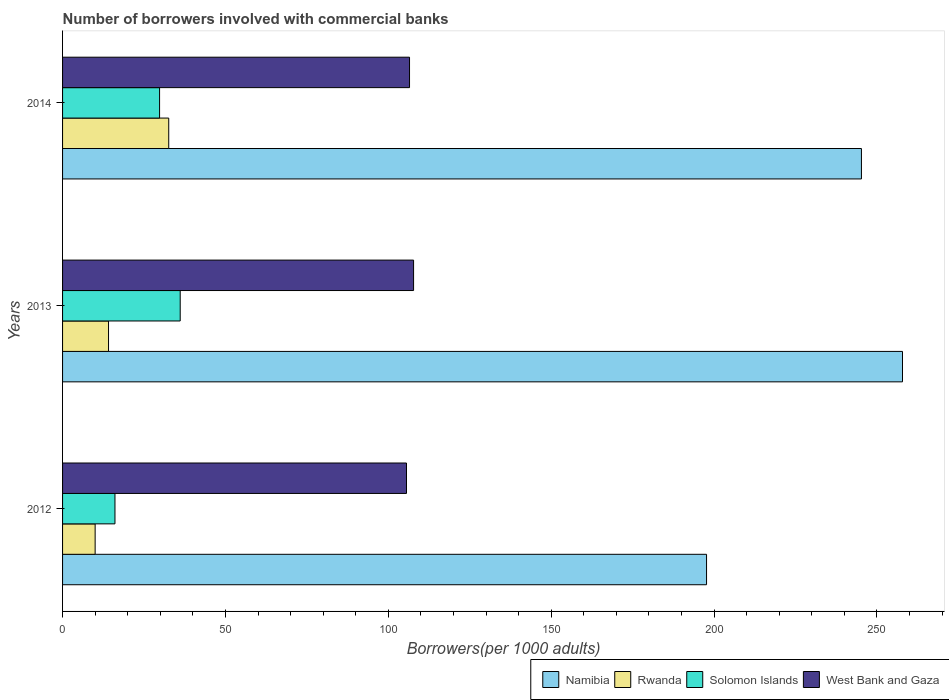How many different coloured bars are there?
Your answer should be very brief. 4. Are the number of bars per tick equal to the number of legend labels?
Your answer should be very brief. Yes. Are the number of bars on each tick of the Y-axis equal?
Ensure brevity in your answer.  Yes. How many bars are there on the 2nd tick from the top?
Your response must be concise. 4. How many bars are there on the 3rd tick from the bottom?
Provide a succinct answer. 4. In how many cases, is the number of bars for a given year not equal to the number of legend labels?
Ensure brevity in your answer.  0. What is the number of borrowers involved with commercial banks in Solomon Islands in 2013?
Give a very brief answer. 36.11. Across all years, what is the maximum number of borrowers involved with commercial banks in Rwanda?
Your answer should be compact. 32.59. Across all years, what is the minimum number of borrowers involved with commercial banks in West Bank and Gaza?
Make the answer very short. 105.58. In which year was the number of borrowers involved with commercial banks in Namibia maximum?
Provide a short and direct response. 2013. In which year was the number of borrowers involved with commercial banks in Solomon Islands minimum?
Your answer should be compact. 2012. What is the total number of borrowers involved with commercial banks in Solomon Islands in the graph?
Offer a terse response. 81.98. What is the difference between the number of borrowers involved with commercial banks in Solomon Islands in 2012 and that in 2014?
Keep it short and to the point. -13.69. What is the difference between the number of borrowers involved with commercial banks in Solomon Islands in 2014 and the number of borrowers involved with commercial banks in Namibia in 2012?
Your answer should be compact. -167.91. What is the average number of borrowers involved with commercial banks in West Bank and Gaza per year?
Provide a short and direct response. 106.61. In the year 2014, what is the difference between the number of borrowers involved with commercial banks in Namibia and number of borrowers involved with commercial banks in West Bank and Gaza?
Your response must be concise. 138.73. In how many years, is the number of borrowers involved with commercial banks in Solomon Islands greater than 110 ?
Your answer should be compact. 0. What is the ratio of the number of borrowers involved with commercial banks in Solomon Islands in 2012 to that in 2013?
Your response must be concise. 0.45. Is the difference between the number of borrowers involved with commercial banks in Namibia in 2013 and 2014 greater than the difference between the number of borrowers involved with commercial banks in West Bank and Gaza in 2013 and 2014?
Offer a terse response. Yes. What is the difference between the highest and the second highest number of borrowers involved with commercial banks in West Bank and Gaza?
Give a very brief answer. 1.24. What is the difference between the highest and the lowest number of borrowers involved with commercial banks in Rwanda?
Provide a short and direct response. 22.59. In how many years, is the number of borrowers involved with commercial banks in West Bank and Gaza greater than the average number of borrowers involved with commercial banks in West Bank and Gaza taken over all years?
Make the answer very short. 1. Is the sum of the number of borrowers involved with commercial banks in Rwanda in 2013 and 2014 greater than the maximum number of borrowers involved with commercial banks in West Bank and Gaza across all years?
Offer a very short reply. No. What does the 3rd bar from the top in 2012 represents?
Offer a very short reply. Rwanda. What does the 1st bar from the bottom in 2012 represents?
Your answer should be very brief. Namibia. Is it the case that in every year, the sum of the number of borrowers involved with commercial banks in Rwanda and number of borrowers involved with commercial banks in Namibia is greater than the number of borrowers involved with commercial banks in Solomon Islands?
Provide a short and direct response. Yes. Are all the bars in the graph horizontal?
Make the answer very short. Yes. How many years are there in the graph?
Ensure brevity in your answer.  3. What is the difference between two consecutive major ticks on the X-axis?
Make the answer very short. 50. Does the graph contain any zero values?
Make the answer very short. No. Does the graph contain grids?
Offer a very short reply. No. How are the legend labels stacked?
Your response must be concise. Horizontal. What is the title of the graph?
Provide a short and direct response. Number of borrowers involved with commercial banks. Does "Gabon" appear as one of the legend labels in the graph?
Give a very brief answer. No. What is the label or title of the X-axis?
Keep it short and to the point. Borrowers(per 1000 adults). What is the Borrowers(per 1000 adults) in Namibia in 2012?
Offer a very short reply. 197.69. What is the Borrowers(per 1000 adults) in Rwanda in 2012?
Your response must be concise. 10. What is the Borrowers(per 1000 adults) in Solomon Islands in 2012?
Offer a very short reply. 16.09. What is the Borrowers(per 1000 adults) in West Bank and Gaza in 2012?
Keep it short and to the point. 105.58. What is the Borrowers(per 1000 adults) of Namibia in 2013?
Give a very brief answer. 257.84. What is the Borrowers(per 1000 adults) of Rwanda in 2013?
Your answer should be compact. 14.11. What is the Borrowers(per 1000 adults) of Solomon Islands in 2013?
Keep it short and to the point. 36.11. What is the Borrowers(per 1000 adults) of West Bank and Gaza in 2013?
Keep it short and to the point. 107.75. What is the Borrowers(per 1000 adults) in Namibia in 2014?
Provide a short and direct response. 245.24. What is the Borrowers(per 1000 adults) of Rwanda in 2014?
Ensure brevity in your answer.  32.59. What is the Borrowers(per 1000 adults) of Solomon Islands in 2014?
Offer a terse response. 29.78. What is the Borrowers(per 1000 adults) of West Bank and Gaza in 2014?
Keep it short and to the point. 106.51. Across all years, what is the maximum Borrowers(per 1000 adults) in Namibia?
Ensure brevity in your answer.  257.84. Across all years, what is the maximum Borrowers(per 1000 adults) of Rwanda?
Your response must be concise. 32.59. Across all years, what is the maximum Borrowers(per 1000 adults) of Solomon Islands?
Offer a very short reply. 36.11. Across all years, what is the maximum Borrowers(per 1000 adults) of West Bank and Gaza?
Your response must be concise. 107.75. Across all years, what is the minimum Borrowers(per 1000 adults) in Namibia?
Ensure brevity in your answer.  197.69. Across all years, what is the minimum Borrowers(per 1000 adults) in Rwanda?
Make the answer very short. 10. Across all years, what is the minimum Borrowers(per 1000 adults) in Solomon Islands?
Offer a terse response. 16.09. Across all years, what is the minimum Borrowers(per 1000 adults) in West Bank and Gaza?
Keep it short and to the point. 105.58. What is the total Borrowers(per 1000 adults) of Namibia in the graph?
Offer a very short reply. 700.77. What is the total Borrowers(per 1000 adults) in Rwanda in the graph?
Offer a terse response. 56.7. What is the total Borrowers(per 1000 adults) in Solomon Islands in the graph?
Your answer should be compact. 81.98. What is the total Borrowers(per 1000 adults) in West Bank and Gaza in the graph?
Provide a short and direct response. 319.84. What is the difference between the Borrowers(per 1000 adults) of Namibia in 2012 and that in 2013?
Provide a succinct answer. -60.15. What is the difference between the Borrowers(per 1000 adults) in Rwanda in 2012 and that in 2013?
Give a very brief answer. -4.11. What is the difference between the Borrowers(per 1000 adults) in Solomon Islands in 2012 and that in 2013?
Make the answer very short. -20.03. What is the difference between the Borrowers(per 1000 adults) of West Bank and Gaza in 2012 and that in 2013?
Ensure brevity in your answer.  -2.17. What is the difference between the Borrowers(per 1000 adults) in Namibia in 2012 and that in 2014?
Give a very brief answer. -47.55. What is the difference between the Borrowers(per 1000 adults) in Rwanda in 2012 and that in 2014?
Make the answer very short. -22.59. What is the difference between the Borrowers(per 1000 adults) in Solomon Islands in 2012 and that in 2014?
Offer a very short reply. -13.69. What is the difference between the Borrowers(per 1000 adults) of West Bank and Gaza in 2012 and that in 2014?
Ensure brevity in your answer.  -0.93. What is the difference between the Borrowers(per 1000 adults) in Namibia in 2013 and that in 2014?
Your response must be concise. 12.6. What is the difference between the Borrowers(per 1000 adults) in Rwanda in 2013 and that in 2014?
Provide a short and direct response. -18.48. What is the difference between the Borrowers(per 1000 adults) in Solomon Islands in 2013 and that in 2014?
Keep it short and to the point. 6.33. What is the difference between the Borrowers(per 1000 adults) of West Bank and Gaza in 2013 and that in 2014?
Offer a terse response. 1.24. What is the difference between the Borrowers(per 1000 adults) in Namibia in 2012 and the Borrowers(per 1000 adults) in Rwanda in 2013?
Make the answer very short. 183.58. What is the difference between the Borrowers(per 1000 adults) of Namibia in 2012 and the Borrowers(per 1000 adults) of Solomon Islands in 2013?
Your answer should be compact. 161.58. What is the difference between the Borrowers(per 1000 adults) of Namibia in 2012 and the Borrowers(per 1000 adults) of West Bank and Gaza in 2013?
Offer a terse response. 89.94. What is the difference between the Borrowers(per 1000 adults) in Rwanda in 2012 and the Borrowers(per 1000 adults) in Solomon Islands in 2013?
Ensure brevity in your answer.  -26.11. What is the difference between the Borrowers(per 1000 adults) of Rwanda in 2012 and the Borrowers(per 1000 adults) of West Bank and Gaza in 2013?
Provide a succinct answer. -97.75. What is the difference between the Borrowers(per 1000 adults) of Solomon Islands in 2012 and the Borrowers(per 1000 adults) of West Bank and Gaza in 2013?
Offer a terse response. -91.66. What is the difference between the Borrowers(per 1000 adults) in Namibia in 2012 and the Borrowers(per 1000 adults) in Rwanda in 2014?
Offer a very short reply. 165.1. What is the difference between the Borrowers(per 1000 adults) in Namibia in 2012 and the Borrowers(per 1000 adults) in Solomon Islands in 2014?
Offer a terse response. 167.91. What is the difference between the Borrowers(per 1000 adults) in Namibia in 2012 and the Borrowers(per 1000 adults) in West Bank and Gaza in 2014?
Your answer should be compact. 91.18. What is the difference between the Borrowers(per 1000 adults) in Rwanda in 2012 and the Borrowers(per 1000 adults) in Solomon Islands in 2014?
Make the answer very short. -19.78. What is the difference between the Borrowers(per 1000 adults) of Rwanda in 2012 and the Borrowers(per 1000 adults) of West Bank and Gaza in 2014?
Your response must be concise. -96.51. What is the difference between the Borrowers(per 1000 adults) of Solomon Islands in 2012 and the Borrowers(per 1000 adults) of West Bank and Gaza in 2014?
Ensure brevity in your answer.  -90.42. What is the difference between the Borrowers(per 1000 adults) in Namibia in 2013 and the Borrowers(per 1000 adults) in Rwanda in 2014?
Keep it short and to the point. 225.25. What is the difference between the Borrowers(per 1000 adults) of Namibia in 2013 and the Borrowers(per 1000 adults) of Solomon Islands in 2014?
Make the answer very short. 228.06. What is the difference between the Borrowers(per 1000 adults) of Namibia in 2013 and the Borrowers(per 1000 adults) of West Bank and Gaza in 2014?
Your response must be concise. 151.33. What is the difference between the Borrowers(per 1000 adults) in Rwanda in 2013 and the Borrowers(per 1000 adults) in Solomon Islands in 2014?
Keep it short and to the point. -15.67. What is the difference between the Borrowers(per 1000 adults) of Rwanda in 2013 and the Borrowers(per 1000 adults) of West Bank and Gaza in 2014?
Offer a very short reply. -92.4. What is the difference between the Borrowers(per 1000 adults) in Solomon Islands in 2013 and the Borrowers(per 1000 adults) in West Bank and Gaza in 2014?
Make the answer very short. -70.4. What is the average Borrowers(per 1000 adults) of Namibia per year?
Ensure brevity in your answer.  233.59. What is the average Borrowers(per 1000 adults) in Rwanda per year?
Your answer should be compact. 18.9. What is the average Borrowers(per 1000 adults) in Solomon Islands per year?
Provide a succinct answer. 27.33. What is the average Borrowers(per 1000 adults) of West Bank and Gaza per year?
Your answer should be very brief. 106.61. In the year 2012, what is the difference between the Borrowers(per 1000 adults) in Namibia and Borrowers(per 1000 adults) in Rwanda?
Offer a very short reply. 187.69. In the year 2012, what is the difference between the Borrowers(per 1000 adults) of Namibia and Borrowers(per 1000 adults) of Solomon Islands?
Provide a short and direct response. 181.6. In the year 2012, what is the difference between the Borrowers(per 1000 adults) in Namibia and Borrowers(per 1000 adults) in West Bank and Gaza?
Give a very brief answer. 92.11. In the year 2012, what is the difference between the Borrowers(per 1000 adults) in Rwanda and Borrowers(per 1000 adults) in Solomon Islands?
Offer a terse response. -6.09. In the year 2012, what is the difference between the Borrowers(per 1000 adults) in Rwanda and Borrowers(per 1000 adults) in West Bank and Gaza?
Provide a succinct answer. -95.58. In the year 2012, what is the difference between the Borrowers(per 1000 adults) in Solomon Islands and Borrowers(per 1000 adults) in West Bank and Gaza?
Provide a short and direct response. -89.49. In the year 2013, what is the difference between the Borrowers(per 1000 adults) in Namibia and Borrowers(per 1000 adults) in Rwanda?
Make the answer very short. 243.73. In the year 2013, what is the difference between the Borrowers(per 1000 adults) of Namibia and Borrowers(per 1000 adults) of Solomon Islands?
Your response must be concise. 221.73. In the year 2013, what is the difference between the Borrowers(per 1000 adults) of Namibia and Borrowers(per 1000 adults) of West Bank and Gaza?
Give a very brief answer. 150.09. In the year 2013, what is the difference between the Borrowers(per 1000 adults) of Rwanda and Borrowers(per 1000 adults) of Solomon Islands?
Provide a succinct answer. -22. In the year 2013, what is the difference between the Borrowers(per 1000 adults) of Rwanda and Borrowers(per 1000 adults) of West Bank and Gaza?
Provide a succinct answer. -93.64. In the year 2013, what is the difference between the Borrowers(per 1000 adults) of Solomon Islands and Borrowers(per 1000 adults) of West Bank and Gaza?
Ensure brevity in your answer.  -71.64. In the year 2014, what is the difference between the Borrowers(per 1000 adults) of Namibia and Borrowers(per 1000 adults) of Rwanda?
Keep it short and to the point. 212.65. In the year 2014, what is the difference between the Borrowers(per 1000 adults) of Namibia and Borrowers(per 1000 adults) of Solomon Islands?
Keep it short and to the point. 215.46. In the year 2014, what is the difference between the Borrowers(per 1000 adults) in Namibia and Borrowers(per 1000 adults) in West Bank and Gaza?
Ensure brevity in your answer.  138.73. In the year 2014, what is the difference between the Borrowers(per 1000 adults) in Rwanda and Borrowers(per 1000 adults) in Solomon Islands?
Your answer should be compact. 2.81. In the year 2014, what is the difference between the Borrowers(per 1000 adults) in Rwanda and Borrowers(per 1000 adults) in West Bank and Gaza?
Offer a terse response. -73.92. In the year 2014, what is the difference between the Borrowers(per 1000 adults) of Solomon Islands and Borrowers(per 1000 adults) of West Bank and Gaza?
Ensure brevity in your answer.  -76.73. What is the ratio of the Borrowers(per 1000 adults) of Namibia in 2012 to that in 2013?
Give a very brief answer. 0.77. What is the ratio of the Borrowers(per 1000 adults) in Rwanda in 2012 to that in 2013?
Offer a very short reply. 0.71. What is the ratio of the Borrowers(per 1000 adults) in Solomon Islands in 2012 to that in 2013?
Ensure brevity in your answer.  0.45. What is the ratio of the Borrowers(per 1000 adults) of West Bank and Gaza in 2012 to that in 2013?
Your answer should be very brief. 0.98. What is the ratio of the Borrowers(per 1000 adults) of Namibia in 2012 to that in 2014?
Make the answer very short. 0.81. What is the ratio of the Borrowers(per 1000 adults) in Rwanda in 2012 to that in 2014?
Your response must be concise. 0.31. What is the ratio of the Borrowers(per 1000 adults) in Solomon Islands in 2012 to that in 2014?
Provide a short and direct response. 0.54. What is the ratio of the Borrowers(per 1000 adults) of West Bank and Gaza in 2012 to that in 2014?
Your answer should be compact. 0.99. What is the ratio of the Borrowers(per 1000 adults) of Namibia in 2013 to that in 2014?
Keep it short and to the point. 1.05. What is the ratio of the Borrowers(per 1000 adults) in Rwanda in 2013 to that in 2014?
Provide a short and direct response. 0.43. What is the ratio of the Borrowers(per 1000 adults) in Solomon Islands in 2013 to that in 2014?
Provide a succinct answer. 1.21. What is the ratio of the Borrowers(per 1000 adults) in West Bank and Gaza in 2013 to that in 2014?
Provide a short and direct response. 1.01. What is the difference between the highest and the second highest Borrowers(per 1000 adults) in Namibia?
Your answer should be very brief. 12.6. What is the difference between the highest and the second highest Borrowers(per 1000 adults) in Rwanda?
Offer a terse response. 18.48. What is the difference between the highest and the second highest Borrowers(per 1000 adults) of Solomon Islands?
Provide a succinct answer. 6.33. What is the difference between the highest and the second highest Borrowers(per 1000 adults) in West Bank and Gaza?
Give a very brief answer. 1.24. What is the difference between the highest and the lowest Borrowers(per 1000 adults) of Namibia?
Make the answer very short. 60.15. What is the difference between the highest and the lowest Borrowers(per 1000 adults) in Rwanda?
Your answer should be compact. 22.59. What is the difference between the highest and the lowest Borrowers(per 1000 adults) in Solomon Islands?
Provide a succinct answer. 20.03. What is the difference between the highest and the lowest Borrowers(per 1000 adults) of West Bank and Gaza?
Provide a succinct answer. 2.17. 